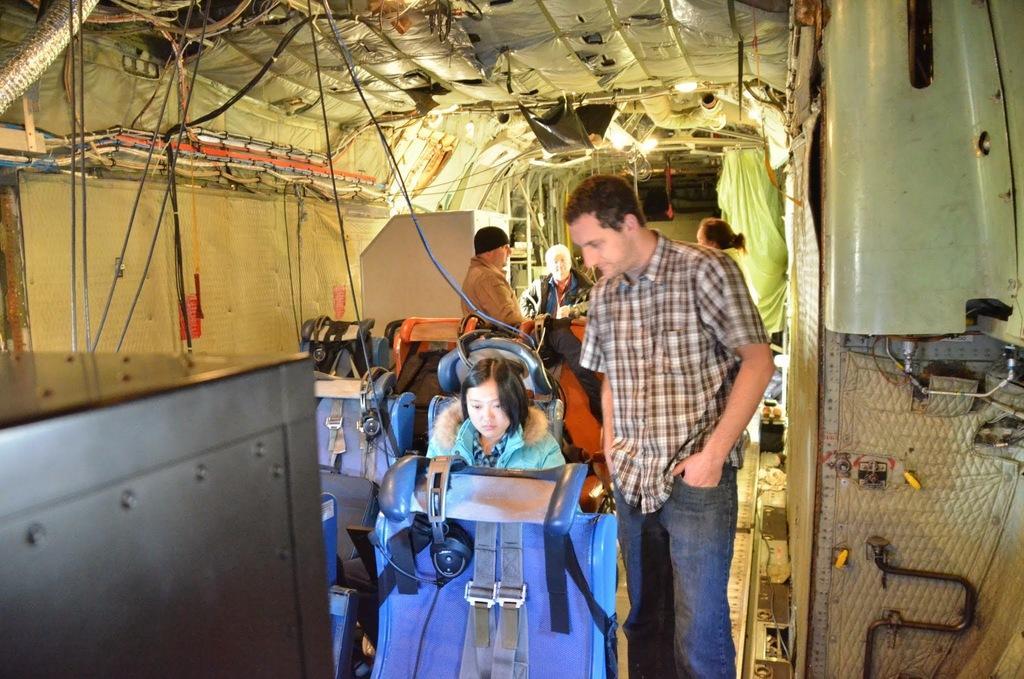Could you give a brief overview of what you see in this image? In this image there is one person standing at right side of this image and there is a woman sitting in middle of this image is wearing blue color jacket and there are some chairs in middle of this image is in blue color. there are some wires connected at top left side of this image, and there is an object at bottom left side of this image and there are some persons at middle of this image and there is one women at right side of this image. 